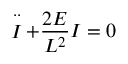<formula> <loc_0><loc_0><loc_500><loc_500>\stackrel { \cdot \cdot } { I } + \frac { 2 E } { L ^ { 2 } } I = 0</formula> 